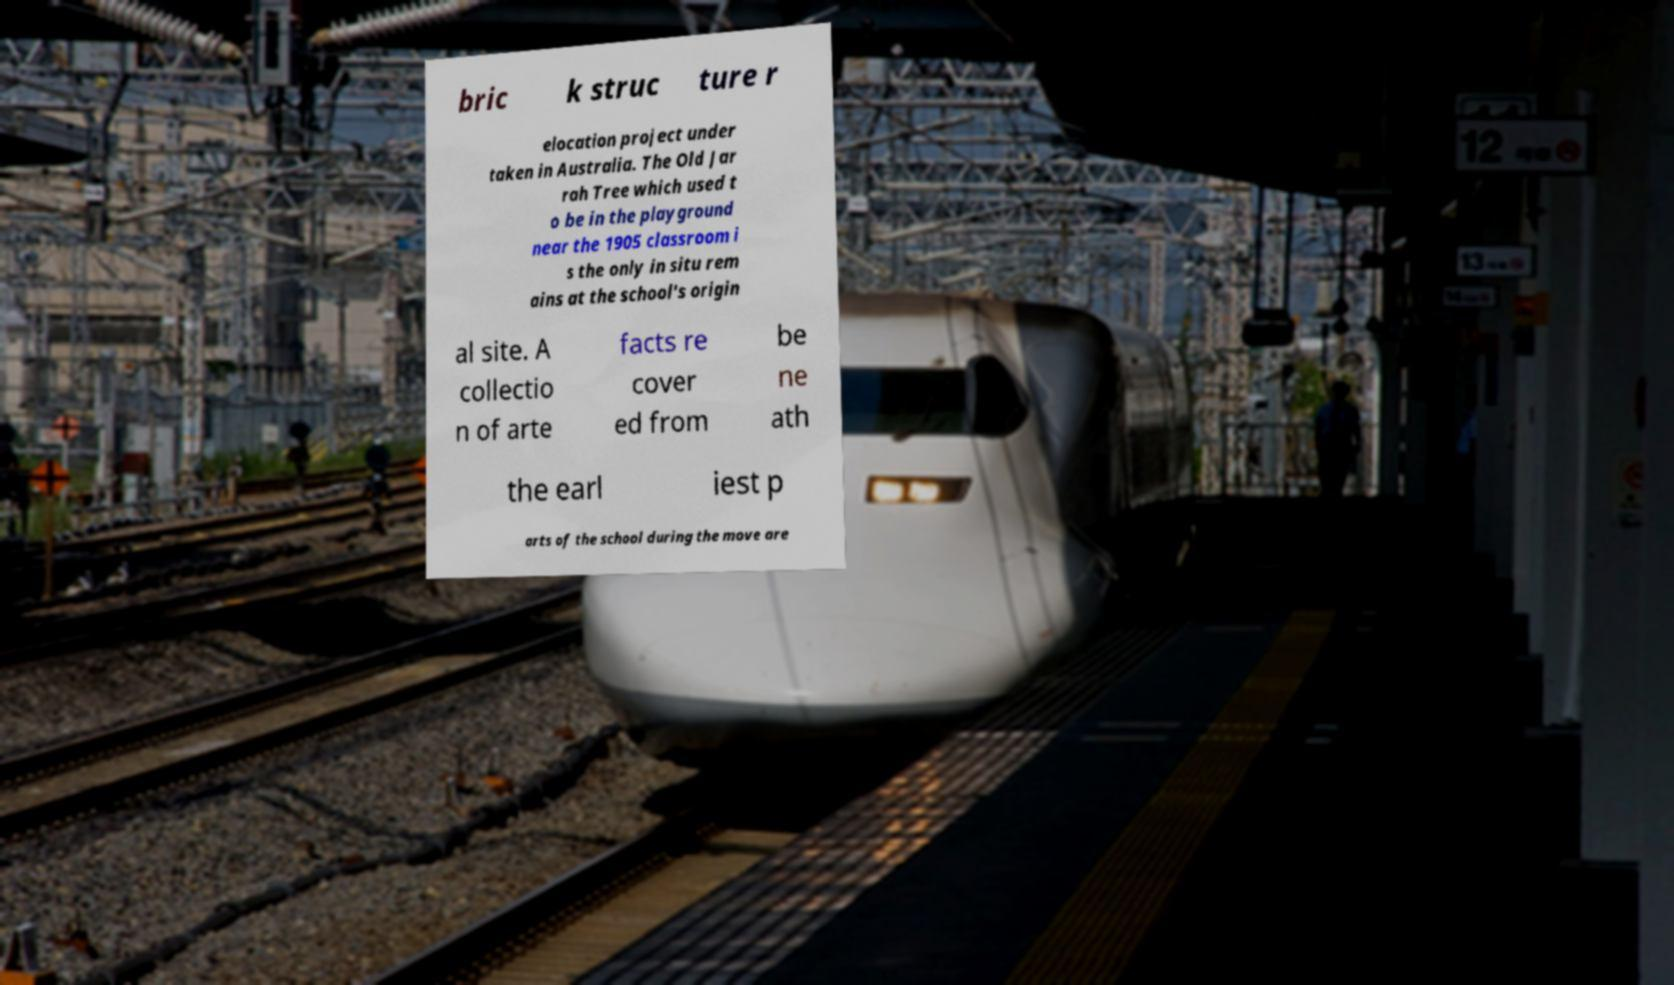For documentation purposes, I need the text within this image transcribed. Could you provide that? bric k struc ture r elocation project under taken in Australia. The Old Jar rah Tree which used t o be in the playground near the 1905 classroom i s the only in situ rem ains at the school's origin al site. A collectio n of arte facts re cover ed from be ne ath the earl iest p arts of the school during the move are 